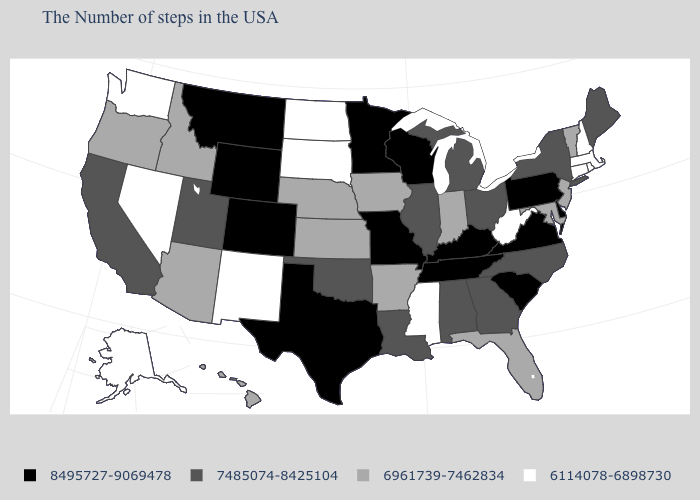What is the value of New York?
Short answer required. 7485074-8425104. Among the states that border Utah , does Colorado have the highest value?
Give a very brief answer. Yes. Among the states that border Pennsylvania , does Ohio have the lowest value?
Give a very brief answer. No. What is the value of New Hampshire?
Give a very brief answer. 6114078-6898730. Name the states that have a value in the range 8495727-9069478?
Quick response, please. Delaware, Pennsylvania, Virginia, South Carolina, Kentucky, Tennessee, Wisconsin, Missouri, Minnesota, Texas, Wyoming, Colorado, Montana. Does the first symbol in the legend represent the smallest category?
Quick response, please. No. What is the value of Oklahoma?
Quick response, please. 7485074-8425104. What is the highest value in states that border South Dakota?
Quick response, please. 8495727-9069478. What is the value of Virginia?
Short answer required. 8495727-9069478. What is the highest value in states that border California?
Keep it brief. 6961739-7462834. Which states have the lowest value in the South?
Write a very short answer. West Virginia, Mississippi. Which states hav the highest value in the West?
Keep it brief. Wyoming, Colorado, Montana. What is the highest value in the USA?
Short answer required. 8495727-9069478. Name the states that have a value in the range 7485074-8425104?
Write a very short answer. Maine, New York, North Carolina, Ohio, Georgia, Michigan, Alabama, Illinois, Louisiana, Oklahoma, Utah, California. Does Idaho have the highest value in the USA?
Give a very brief answer. No. 